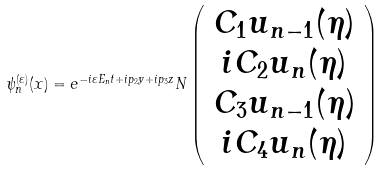Convert formula to latex. <formula><loc_0><loc_0><loc_500><loc_500>\psi ^ { ( \varepsilon ) } _ { n } ( x ) = e ^ { - i \varepsilon E _ { n } t + i p _ { 2 } y + i p _ { 3 } z } N \left ( \begin{array} { c } C _ { 1 } u _ { n - 1 } ( \eta ) \\ i C _ { 2 } u _ { n } ( \eta ) \\ C _ { 3 } u _ { n - 1 } ( \eta ) \\ i C _ { 4 } u _ { n } ( \eta ) \end{array} \right )</formula> 